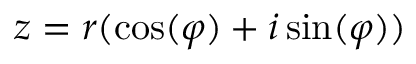Convert formula to latex. <formula><loc_0><loc_0><loc_500><loc_500>z = r ( \cos ( \varphi ) + i \sin ( \varphi ) )</formula> 